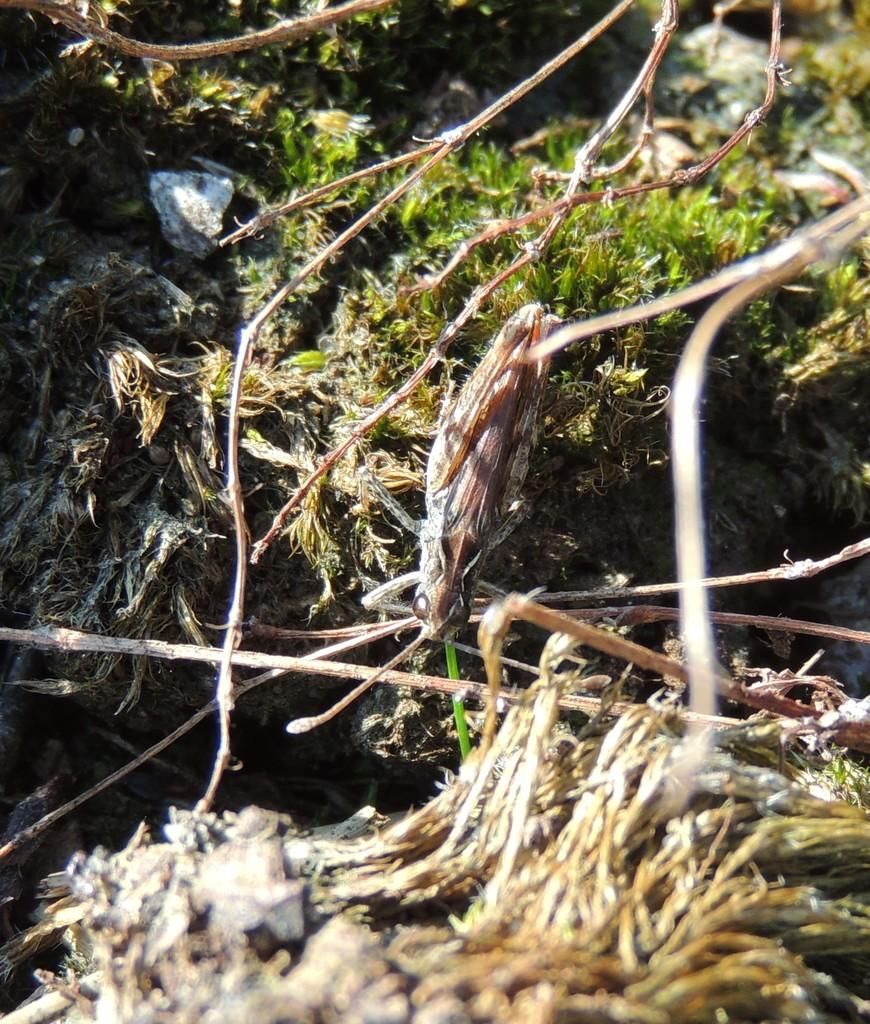What type of creature can be seen in the image? There is an insect in the image. What natural elements are present in the image? There are branches and grass in the image. What type of cast can be seen on the insect in the image? There is no cast present on the insect in the image. Are there any bears visible in the image? There are no bears present in the image. 